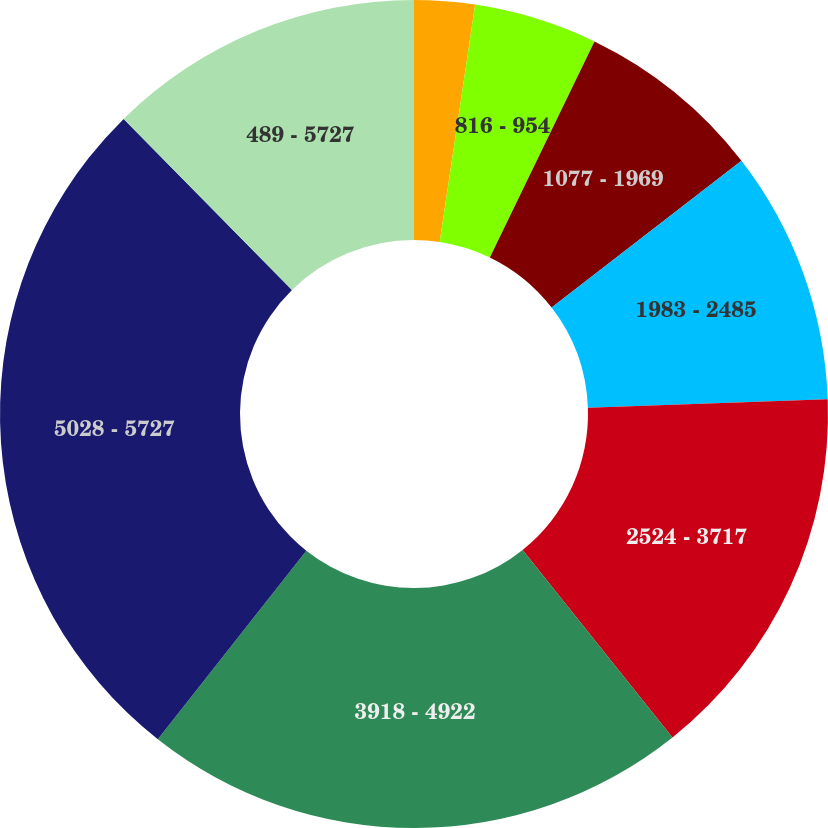Convert chart to OTSL. <chart><loc_0><loc_0><loc_500><loc_500><pie_chart><fcel>489 - 570<fcel>816 - 954<fcel>1077 - 1969<fcel>1983 - 2485<fcel>2524 - 3717<fcel>3918 - 4922<fcel>5028 - 5727<fcel>489 - 5727<nl><fcel>2.36%<fcel>4.82%<fcel>7.34%<fcel>9.91%<fcel>14.84%<fcel>21.35%<fcel>27.01%<fcel>12.37%<nl></chart> 